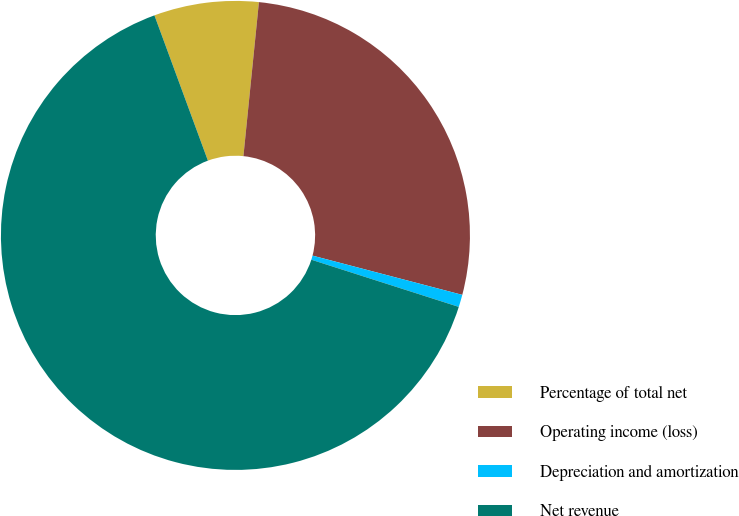Convert chart. <chart><loc_0><loc_0><loc_500><loc_500><pie_chart><fcel>Percentage of total net<fcel>Operating income (loss)<fcel>Depreciation and amortization<fcel>Net revenue<nl><fcel>7.21%<fcel>27.48%<fcel>0.85%<fcel>64.45%<nl></chart> 